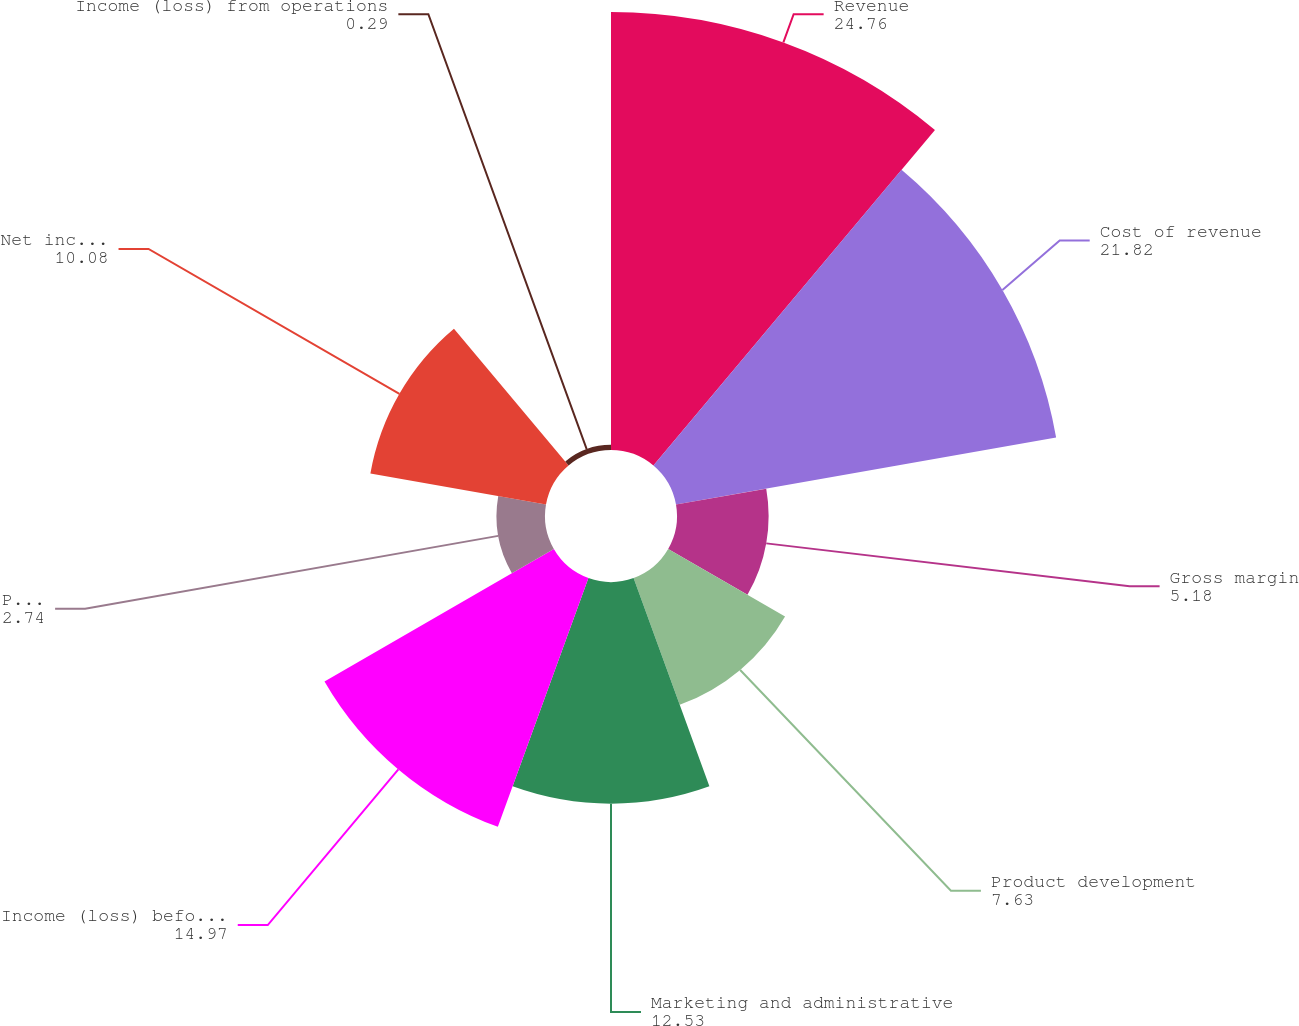Convert chart. <chart><loc_0><loc_0><loc_500><loc_500><pie_chart><fcel>Revenue<fcel>Cost of revenue<fcel>Gross margin<fcel>Product development<fcel>Marketing and administrative<fcel>Income (loss) before income<fcel>Provision for (benefit from)<fcel>Net income (loss)<fcel>Income (loss) from operations<nl><fcel>24.76%<fcel>21.82%<fcel>5.18%<fcel>7.63%<fcel>12.53%<fcel>14.97%<fcel>2.74%<fcel>10.08%<fcel>0.29%<nl></chart> 